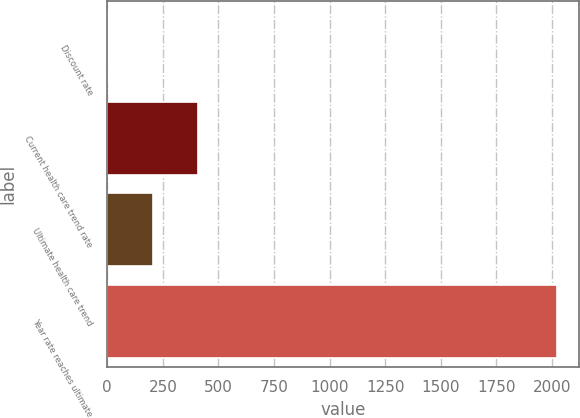<chart> <loc_0><loc_0><loc_500><loc_500><bar_chart><fcel>Discount rate<fcel>Current health care trend rate<fcel>Ultimate health care trend<fcel>Year rate reaches ultimate<nl><fcel>4.6<fcel>408.28<fcel>206.44<fcel>2023<nl></chart> 